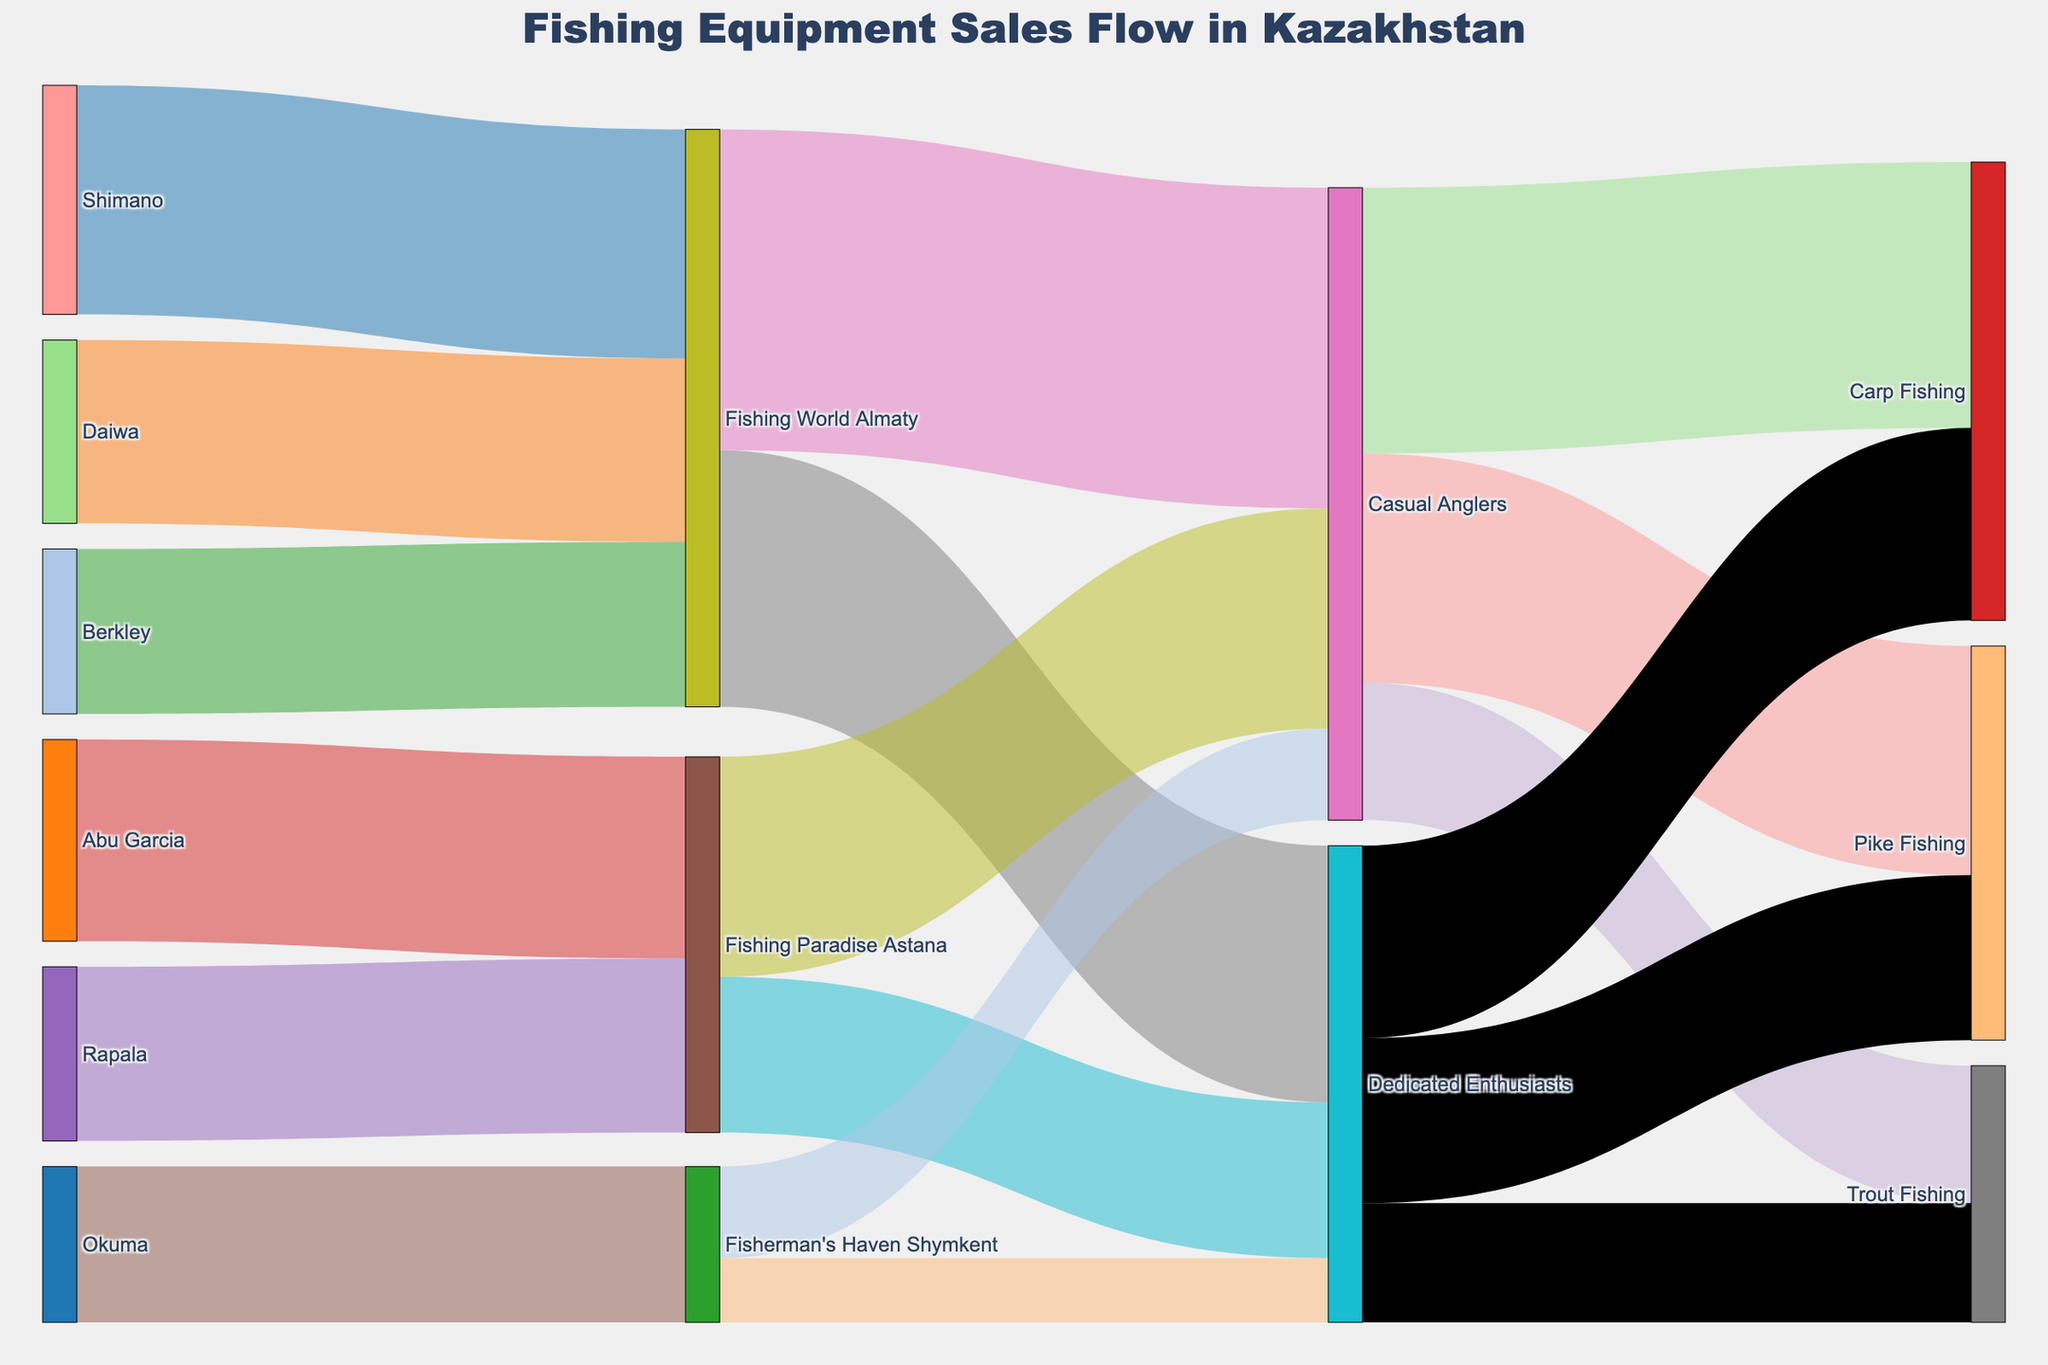How many different manufacturers are shown in the Sankey Diagram? Count the number of unique manufacturers listed on the left side of the diagram.
Answer: 6 Which retailer receives the highest quantity of equipment from the manufacturers? Compare the values corresponding to each retailer from the manufacturers and find the one with the largest value.
Answer: Fishing World Almaty Out of the following groups—Casual Anglers, Dedicated Enthusiasts, and specific fish type segments like Carp Fishing or Pike Fishing—which category has the highest total value? Add up the total values associated with Casual Anglers and Dedicated Enthusiasts, respectively, and compare those totals to specific fish type segments.
Answer: Casual Anglers What is the total sales value that Shimano contributes to retailers? Sum up the values originating from Shimano to various retailers as indicated in the diagram.
Answer: 2500 Which pathway shows the least flow of fishing equipment from retailers to consumer segments? Identify the arrows between retailers and consumer segments on the far right, noting the arrow with the smallest value.
Answer: Fisherman's Haven Shymkent to Dedicated Enthusiasts How many unique consumer segments are identified in the diagram? Count the distinct segments listed at the far right of the diagram.
Answer: 3 Compare the sales values from Abu Garcia and Rapala to Fishing Paradise Astana. Which one is higher? Look at the values linked from Abu Garcia and Rapala to Fishing Paradise Astana and determine the larger value.
Answer: Abu Garcia Calculate the percentage of Daiwa's total contribution relative to the sum of contributions from all manufacturers. Calculate the total sum of all values originating from manufacturers, then divide Daiwa's contribution by this sum and multiply by 100 to find the percentage.
Answer: Need calculation steps Do Casual Anglers or Dedicated Enthusiasts purchase more Carp Fishing equipment? Compare the values flowing to Carp Fishing from Casual Anglers and Dedicated Enthusiasts.
Answer: Casual Anglers What fish type segment receives the highest total value from both Casual Anglers and Dedicated Enthusiasts? Add up the values flowing to each fish type segment from both Casual Anglers and Dedicated Enthusiasts, then compare the totals.
Answer: Carp Fishing 